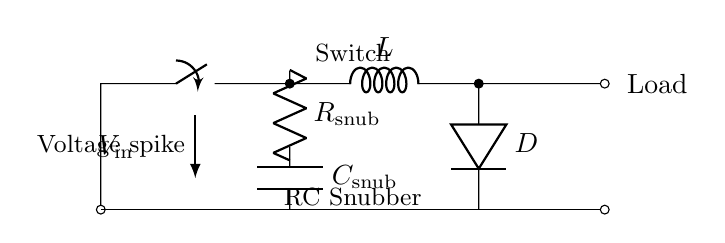What component is used for voltage clamping? The component used for voltage clamping in this circuit is the diode, labeled D. When voltage spikes occur, the diode conducts and helps protect the circuit by diverting excessive voltage.
Answer: Diode What is the role of the capacitor in this RC snubber circuit? The capacitor, labeled C, absorbs voltage spikes by charging and discharging in response to the changes in voltage. This helps smooth out any sudden surges, providing a more stable voltage to the load.
Answer: Absorbs voltage spikes What does the resistor in this circuit do? The resistor, labeled R snub, dampens oscillations in the circuit. It works in conjunction with the capacitor to control the rate of charge and discharge, reducing ringing and improving the response time of the circuit.
Answer: Dampen oscillations How many components are there in the snubber circuit? The circuit contains three main components: one resistor (R snub), one capacitor (C snub), and one diode (D). Each plays a critical role in reducing voltage spikes and smoothing the output.
Answer: Three Which component directly connects to the load? The load is directly connected to the inductor L, which follows the switch in the circuit. This connection allows the load to receive current from the inductor when the switch is closed, with the snubber components working to protect against voltage spikes.
Answer: Inductor What does the switch control in this circuit? The switch controls the connectivity during operation, allowing current to flow from the input voltage to the circuit and thus enabling or disabling the power supplied to the load. When closed, it allows current flow; when open, it interrupts the flow.
Answer: Connectivity 